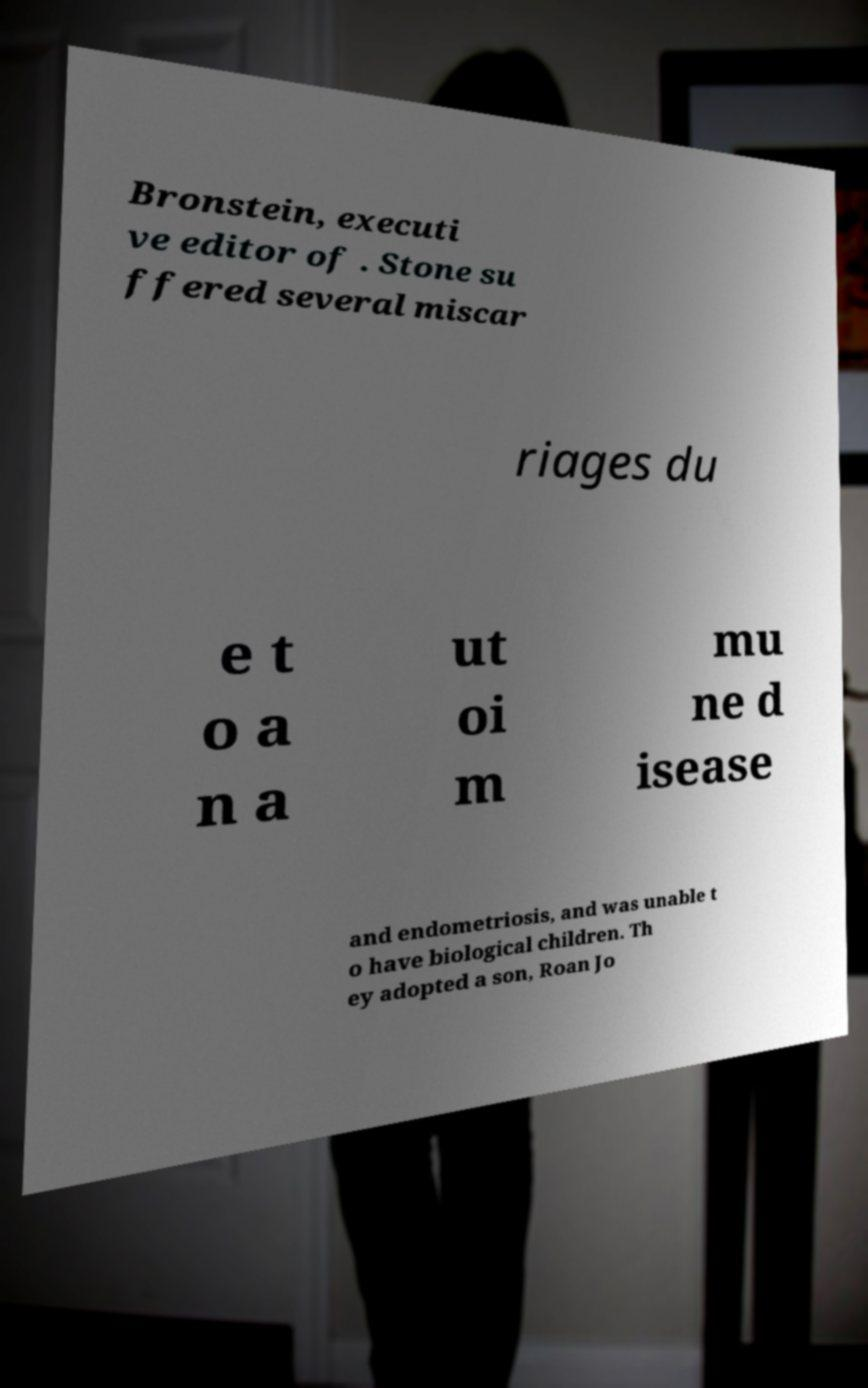Please identify and transcribe the text found in this image. Bronstein, executi ve editor of . Stone su ffered several miscar riages du e t o a n a ut oi m mu ne d isease and endometriosis, and was unable t o have biological children. Th ey adopted a son, Roan Jo 